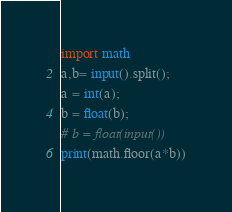Convert code to text. <code><loc_0><loc_0><loc_500><loc_500><_Python_>import math
a,b= input().split();
a = int(a);
b = float(b);
# b = float(input())
print(math.floor(a*b))</code> 